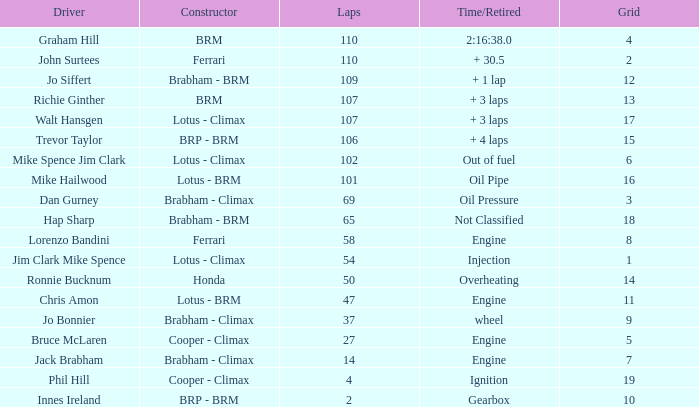Who is the driver with a time/retired duration of 2:16:38.0? Graham Hill. 